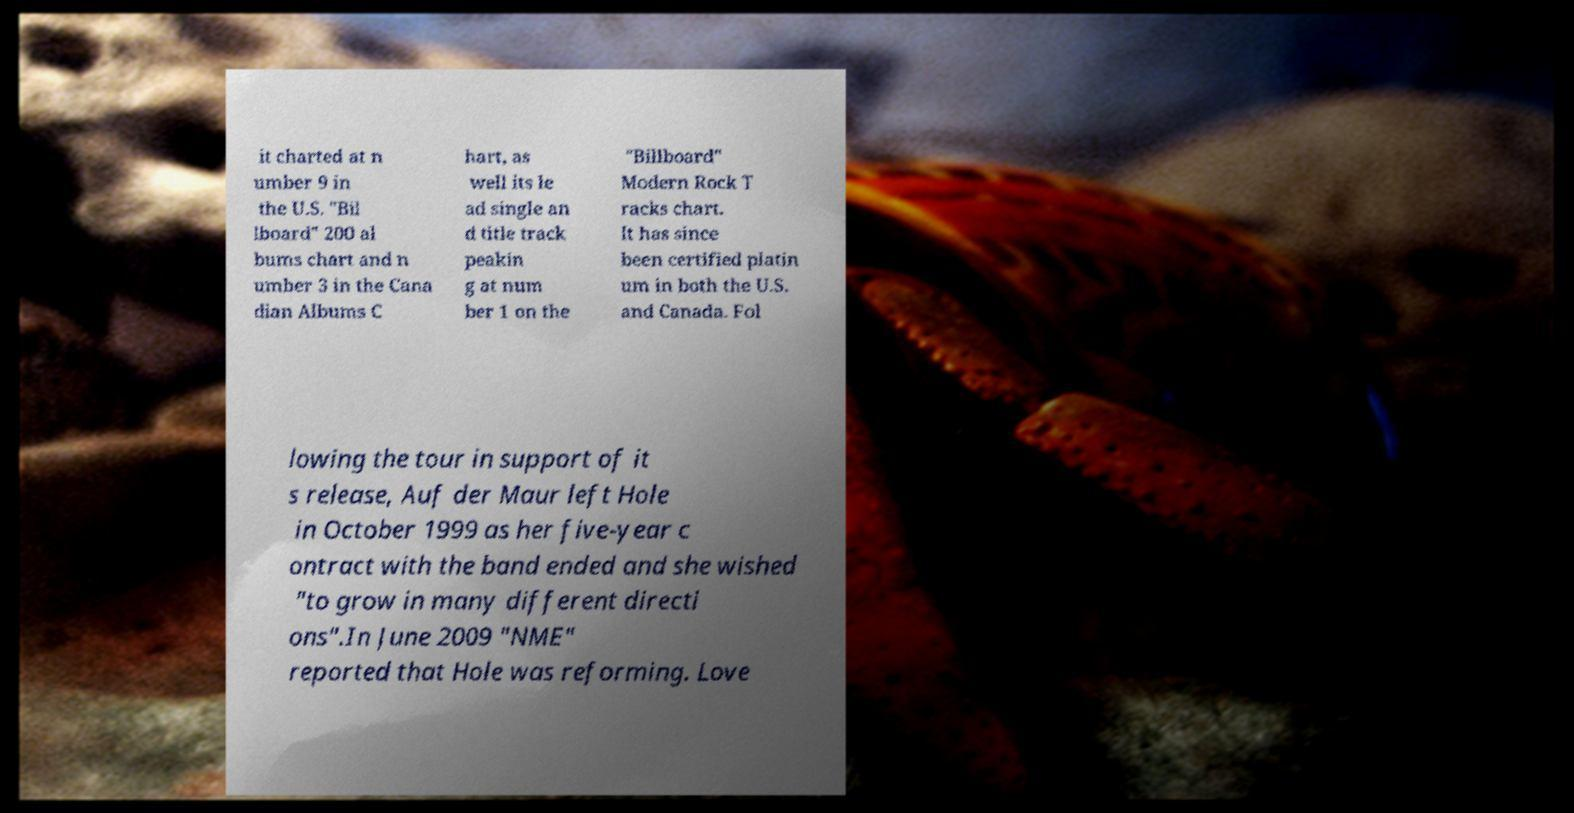Please identify and transcribe the text found in this image. it charted at n umber 9 in the U.S. "Bil lboard" 200 al bums chart and n umber 3 in the Cana dian Albums C hart, as well its le ad single an d title track peakin g at num ber 1 on the "Billboard" Modern Rock T racks chart. It has since been certified platin um in both the U.S. and Canada. Fol lowing the tour in support of it s release, Auf der Maur left Hole in October 1999 as her five-year c ontract with the band ended and she wished "to grow in many different directi ons".In June 2009 "NME" reported that Hole was reforming. Love 